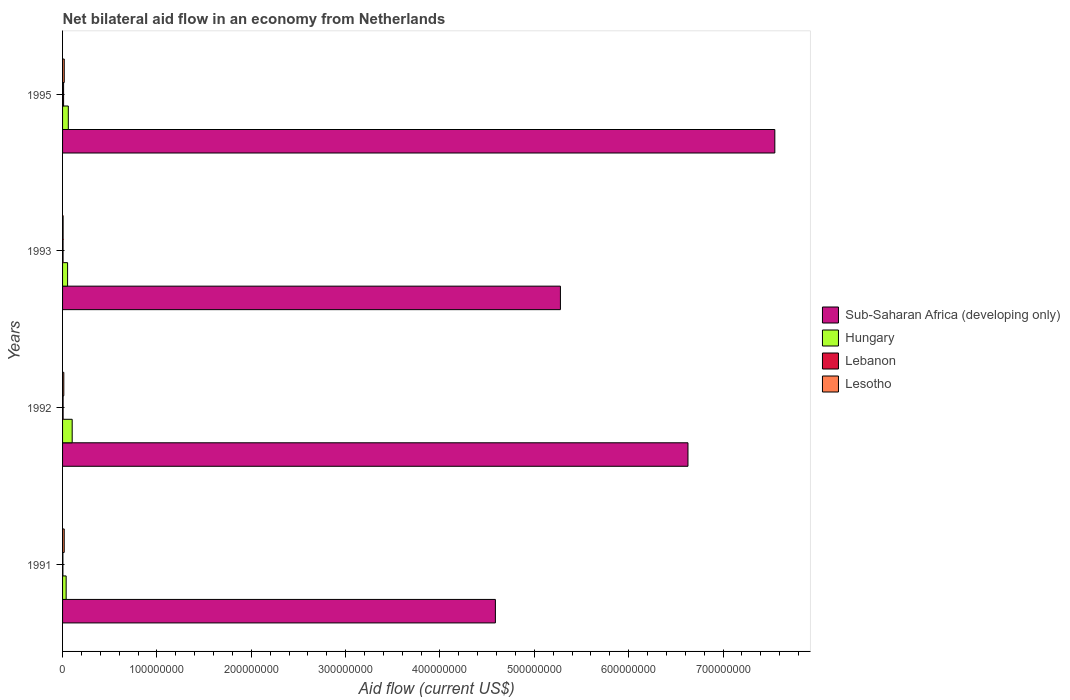Are the number of bars per tick equal to the number of legend labels?
Provide a short and direct response. Yes. Are the number of bars on each tick of the Y-axis equal?
Your answer should be compact. Yes. How many bars are there on the 2nd tick from the top?
Provide a short and direct response. 4. How many bars are there on the 2nd tick from the bottom?
Offer a terse response. 4. What is the label of the 4th group of bars from the top?
Offer a very short reply. 1991. In how many cases, is the number of bars for a given year not equal to the number of legend labels?
Your response must be concise. 0. What is the net bilateral aid flow in Sub-Saharan Africa (developing only) in 1992?
Provide a short and direct response. 6.63e+08. Across all years, what is the maximum net bilateral aid flow in Sub-Saharan Africa (developing only)?
Give a very brief answer. 7.55e+08. Across all years, what is the minimum net bilateral aid flow in Sub-Saharan Africa (developing only)?
Keep it short and to the point. 4.59e+08. In which year was the net bilateral aid flow in Hungary maximum?
Make the answer very short. 1992. In which year was the net bilateral aid flow in Lesotho minimum?
Offer a very short reply. 1993. What is the total net bilateral aid flow in Lebanon in the graph?
Keep it short and to the point. 2.55e+06. What is the difference between the net bilateral aid flow in Lesotho in 1993 and that in 1995?
Offer a very short reply. -1.20e+06. What is the difference between the net bilateral aid flow in Lesotho in 1991 and the net bilateral aid flow in Sub-Saharan Africa (developing only) in 1995?
Offer a terse response. -7.53e+08. What is the average net bilateral aid flow in Hungary per year?
Provide a succinct answer. 6.36e+06. In the year 1993, what is the difference between the net bilateral aid flow in Hungary and net bilateral aid flow in Lesotho?
Ensure brevity in your answer.  4.75e+06. What is the ratio of the net bilateral aid flow in Lebanon in 1991 to that in 1995?
Provide a succinct answer. 0.33. What is the difference between the highest and the lowest net bilateral aid flow in Sub-Saharan Africa (developing only)?
Ensure brevity in your answer.  2.96e+08. In how many years, is the net bilateral aid flow in Sub-Saharan Africa (developing only) greater than the average net bilateral aid flow in Sub-Saharan Africa (developing only) taken over all years?
Make the answer very short. 2. Is the sum of the net bilateral aid flow in Lebanon in 1991 and 1992 greater than the maximum net bilateral aid flow in Hungary across all years?
Keep it short and to the point. No. What does the 1st bar from the top in 1993 represents?
Your answer should be compact. Lesotho. What does the 2nd bar from the bottom in 1991 represents?
Offer a terse response. Hungary. Is it the case that in every year, the sum of the net bilateral aid flow in Sub-Saharan Africa (developing only) and net bilateral aid flow in Hungary is greater than the net bilateral aid flow in Lesotho?
Your answer should be very brief. Yes. How many bars are there?
Make the answer very short. 16. Are all the bars in the graph horizontal?
Provide a short and direct response. Yes. How many years are there in the graph?
Give a very brief answer. 4. Are the values on the major ticks of X-axis written in scientific E-notation?
Provide a short and direct response. No. Does the graph contain any zero values?
Your answer should be compact. No. How many legend labels are there?
Provide a succinct answer. 4. What is the title of the graph?
Offer a terse response. Net bilateral aid flow in an economy from Netherlands. Does "Guinea-Bissau" appear as one of the legend labels in the graph?
Ensure brevity in your answer.  No. What is the label or title of the X-axis?
Offer a very short reply. Aid flow (current US$). What is the label or title of the Y-axis?
Your response must be concise. Years. What is the Aid flow (current US$) in Sub-Saharan Africa (developing only) in 1991?
Your answer should be compact. 4.59e+08. What is the Aid flow (current US$) of Hungary in 1991?
Make the answer very short. 3.80e+06. What is the Aid flow (current US$) of Lebanon in 1991?
Provide a succinct answer. 3.60e+05. What is the Aid flow (current US$) in Lesotho in 1991?
Offer a very short reply. 1.75e+06. What is the Aid flow (current US$) of Sub-Saharan Africa (developing only) in 1992?
Offer a terse response. 6.63e+08. What is the Aid flow (current US$) in Hungary in 1992?
Keep it short and to the point. 1.02e+07. What is the Aid flow (current US$) in Lebanon in 1992?
Your answer should be very brief. 5.80e+05. What is the Aid flow (current US$) of Lesotho in 1992?
Make the answer very short. 1.32e+06. What is the Aid flow (current US$) in Sub-Saharan Africa (developing only) in 1993?
Your answer should be very brief. 5.28e+08. What is the Aid flow (current US$) of Hungary in 1993?
Offer a terse response. 5.33e+06. What is the Aid flow (current US$) of Lebanon in 1993?
Your answer should be very brief. 5.20e+05. What is the Aid flow (current US$) of Lesotho in 1993?
Ensure brevity in your answer.  5.80e+05. What is the Aid flow (current US$) in Sub-Saharan Africa (developing only) in 1995?
Give a very brief answer. 7.55e+08. What is the Aid flow (current US$) in Hungary in 1995?
Make the answer very short. 6.09e+06. What is the Aid flow (current US$) of Lebanon in 1995?
Ensure brevity in your answer.  1.09e+06. What is the Aid flow (current US$) in Lesotho in 1995?
Ensure brevity in your answer.  1.78e+06. Across all years, what is the maximum Aid flow (current US$) of Sub-Saharan Africa (developing only)?
Provide a short and direct response. 7.55e+08. Across all years, what is the maximum Aid flow (current US$) of Hungary?
Provide a succinct answer. 1.02e+07. Across all years, what is the maximum Aid flow (current US$) of Lebanon?
Ensure brevity in your answer.  1.09e+06. Across all years, what is the maximum Aid flow (current US$) in Lesotho?
Your answer should be very brief. 1.78e+06. Across all years, what is the minimum Aid flow (current US$) in Sub-Saharan Africa (developing only)?
Offer a very short reply. 4.59e+08. Across all years, what is the minimum Aid flow (current US$) of Hungary?
Offer a terse response. 3.80e+06. Across all years, what is the minimum Aid flow (current US$) of Lebanon?
Provide a short and direct response. 3.60e+05. Across all years, what is the minimum Aid flow (current US$) in Lesotho?
Keep it short and to the point. 5.80e+05. What is the total Aid flow (current US$) in Sub-Saharan Africa (developing only) in the graph?
Your response must be concise. 2.40e+09. What is the total Aid flow (current US$) in Hungary in the graph?
Your response must be concise. 2.54e+07. What is the total Aid flow (current US$) in Lebanon in the graph?
Provide a short and direct response. 2.55e+06. What is the total Aid flow (current US$) of Lesotho in the graph?
Give a very brief answer. 5.43e+06. What is the difference between the Aid flow (current US$) of Sub-Saharan Africa (developing only) in 1991 and that in 1992?
Provide a succinct answer. -2.04e+08. What is the difference between the Aid flow (current US$) in Hungary in 1991 and that in 1992?
Your response must be concise. -6.40e+06. What is the difference between the Aid flow (current US$) in Sub-Saharan Africa (developing only) in 1991 and that in 1993?
Provide a short and direct response. -6.89e+07. What is the difference between the Aid flow (current US$) of Hungary in 1991 and that in 1993?
Your answer should be very brief. -1.53e+06. What is the difference between the Aid flow (current US$) of Lesotho in 1991 and that in 1993?
Provide a succinct answer. 1.17e+06. What is the difference between the Aid flow (current US$) of Sub-Saharan Africa (developing only) in 1991 and that in 1995?
Your response must be concise. -2.96e+08. What is the difference between the Aid flow (current US$) in Hungary in 1991 and that in 1995?
Provide a succinct answer. -2.29e+06. What is the difference between the Aid flow (current US$) in Lebanon in 1991 and that in 1995?
Make the answer very short. -7.30e+05. What is the difference between the Aid flow (current US$) in Sub-Saharan Africa (developing only) in 1992 and that in 1993?
Your response must be concise. 1.35e+08. What is the difference between the Aid flow (current US$) of Hungary in 1992 and that in 1993?
Offer a terse response. 4.87e+06. What is the difference between the Aid flow (current US$) of Lesotho in 1992 and that in 1993?
Provide a succinct answer. 7.40e+05. What is the difference between the Aid flow (current US$) in Sub-Saharan Africa (developing only) in 1992 and that in 1995?
Offer a very short reply. -9.21e+07. What is the difference between the Aid flow (current US$) in Hungary in 1992 and that in 1995?
Offer a very short reply. 4.11e+06. What is the difference between the Aid flow (current US$) of Lebanon in 1992 and that in 1995?
Make the answer very short. -5.10e+05. What is the difference between the Aid flow (current US$) of Lesotho in 1992 and that in 1995?
Provide a short and direct response. -4.60e+05. What is the difference between the Aid flow (current US$) in Sub-Saharan Africa (developing only) in 1993 and that in 1995?
Provide a succinct answer. -2.27e+08. What is the difference between the Aid flow (current US$) in Hungary in 1993 and that in 1995?
Offer a very short reply. -7.60e+05. What is the difference between the Aid flow (current US$) of Lebanon in 1993 and that in 1995?
Keep it short and to the point. -5.70e+05. What is the difference between the Aid flow (current US$) in Lesotho in 1993 and that in 1995?
Make the answer very short. -1.20e+06. What is the difference between the Aid flow (current US$) in Sub-Saharan Africa (developing only) in 1991 and the Aid flow (current US$) in Hungary in 1992?
Your answer should be compact. 4.49e+08. What is the difference between the Aid flow (current US$) in Sub-Saharan Africa (developing only) in 1991 and the Aid flow (current US$) in Lebanon in 1992?
Make the answer very short. 4.58e+08. What is the difference between the Aid flow (current US$) of Sub-Saharan Africa (developing only) in 1991 and the Aid flow (current US$) of Lesotho in 1992?
Ensure brevity in your answer.  4.57e+08. What is the difference between the Aid flow (current US$) of Hungary in 1991 and the Aid flow (current US$) of Lebanon in 1992?
Offer a very short reply. 3.22e+06. What is the difference between the Aid flow (current US$) of Hungary in 1991 and the Aid flow (current US$) of Lesotho in 1992?
Offer a very short reply. 2.48e+06. What is the difference between the Aid flow (current US$) in Lebanon in 1991 and the Aid flow (current US$) in Lesotho in 1992?
Make the answer very short. -9.60e+05. What is the difference between the Aid flow (current US$) of Sub-Saharan Africa (developing only) in 1991 and the Aid flow (current US$) of Hungary in 1993?
Give a very brief answer. 4.53e+08. What is the difference between the Aid flow (current US$) in Sub-Saharan Africa (developing only) in 1991 and the Aid flow (current US$) in Lebanon in 1993?
Your answer should be compact. 4.58e+08. What is the difference between the Aid flow (current US$) in Sub-Saharan Africa (developing only) in 1991 and the Aid flow (current US$) in Lesotho in 1993?
Make the answer very short. 4.58e+08. What is the difference between the Aid flow (current US$) of Hungary in 1991 and the Aid flow (current US$) of Lebanon in 1993?
Your response must be concise. 3.28e+06. What is the difference between the Aid flow (current US$) of Hungary in 1991 and the Aid flow (current US$) of Lesotho in 1993?
Your response must be concise. 3.22e+06. What is the difference between the Aid flow (current US$) in Lebanon in 1991 and the Aid flow (current US$) in Lesotho in 1993?
Your answer should be compact. -2.20e+05. What is the difference between the Aid flow (current US$) in Sub-Saharan Africa (developing only) in 1991 and the Aid flow (current US$) in Hungary in 1995?
Offer a very short reply. 4.53e+08. What is the difference between the Aid flow (current US$) of Sub-Saharan Africa (developing only) in 1991 and the Aid flow (current US$) of Lebanon in 1995?
Your answer should be very brief. 4.58e+08. What is the difference between the Aid flow (current US$) in Sub-Saharan Africa (developing only) in 1991 and the Aid flow (current US$) in Lesotho in 1995?
Your response must be concise. 4.57e+08. What is the difference between the Aid flow (current US$) of Hungary in 1991 and the Aid flow (current US$) of Lebanon in 1995?
Ensure brevity in your answer.  2.71e+06. What is the difference between the Aid flow (current US$) of Hungary in 1991 and the Aid flow (current US$) of Lesotho in 1995?
Offer a very short reply. 2.02e+06. What is the difference between the Aid flow (current US$) in Lebanon in 1991 and the Aid flow (current US$) in Lesotho in 1995?
Provide a succinct answer. -1.42e+06. What is the difference between the Aid flow (current US$) of Sub-Saharan Africa (developing only) in 1992 and the Aid flow (current US$) of Hungary in 1993?
Your answer should be compact. 6.58e+08. What is the difference between the Aid flow (current US$) in Sub-Saharan Africa (developing only) in 1992 and the Aid flow (current US$) in Lebanon in 1993?
Give a very brief answer. 6.62e+08. What is the difference between the Aid flow (current US$) in Sub-Saharan Africa (developing only) in 1992 and the Aid flow (current US$) in Lesotho in 1993?
Your response must be concise. 6.62e+08. What is the difference between the Aid flow (current US$) of Hungary in 1992 and the Aid flow (current US$) of Lebanon in 1993?
Ensure brevity in your answer.  9.68e+06. What is the difference between the Aid flow (current US$) of Hungary in 1992 and the Aid flow (current US$) of Lesotho in 1993?
Make the answer very short. 9.62e+06. What is the difference between the Aid flow (current US$) of Sub-Saharan Africa (developing only) in 1992 and the Aid flow (current US$) of Hungary in 1995?
Your response must be concise. 6.57e+08. What is the difference between the Aid flow (current US$) in Sub-Saharan Africa (developing only) in 1992 and the Aid flow (current US$) in Lebanon in 1995?
Make the answer very short. 6.62e+08. What is the difference between the Aid flow (current US$) of Sub-Saharan Africa (developing only) in 1992 and the Aid flow (current US$) of Lesotho in 1995?
Provide a succinct answer. 6.61e+08. What is the difference between the Aid flow (current US$) of Hungary in 1992 and the Aid flow (current US$) of Lebanon in 1995?
Provide a short and direct response. 9.11e+06. What is the difference between the Aid flow (current US$) of Hungary in 1992 and the Aid flow (current US$) of Lesotho in 1995?
Your response must be concise. 8.42e+06. What is the difference between the Aid flow (current US$) in Lebanon in 1992 and the Aid flow (current US$) in Lesotho in 1995?
Offer a terse response. -1.20e+06. What is the difference between the Aid flow (current US$) in Sub-Saharan Africa (developing only) in 1993 and the Aid flow (current US$) in Hungary in 1995?
Provide a succinct answer. 5.22e+08. What is the difference between the Aid flow (current US$) in Sub-Saharan Africa (developing only) in 1993 and the Aid flow (current US$) in Lebanon in 1995?
Keep it short and to the point. 5.27e+08. What is the difference between the Aid flow (current US$) in Sub-Saharan Africa (developing only) in 1993 and the Aid flow (current US$) in Lesotho in 1995?
Offer a terse response. 5.26e+08. What is the difference between the Aid flow (current US$) in Hungary in 1993 and the Aid flow (current US$) in Lebanon in 1995?
Your answer should be very brief. 4.24e+06. What is the difference between the Aid flow (current US$) of Hungary in 1993 and the Aid flow (current US$) of Lesotho in 1995?
Your response must be concise. 3.55e+06. What is the difference between the Aid flow (current US$) of Lebanon in 1993 and the Aid flow (current US$) of Lesotho in 1995?
Give a very brief answer. -1.26e+06. What is the average Aid flow (current US$) of Sub-Saharan Africa (developing only) per year?
Ensure brevity in your answer.  6.01e+08. What is the average Aid flow (current US$) of Hungary per year?
Provide a succinct answer. 6.36e+06. What is the average Aid flow (current US$) in Lebanon per year?
Make the answer very short. 6.38e+05. What is the average Aid flow (current US$) in Lesotho per year?
Your response must be concise. 1.36e+06. In the year 1991, what is the difference between the Aid flow (current US$) of Sub-Saharan Africa (developing only) and Aid flow (current US$) of Hungary?
Your response must be concise. 4.55e+08. In the year 1991, what is the difference between the Aid flow (current US$) of Sub-Saharan Africa (developing only) and Aid flow (current US$) of Lebanon?
Offer a terse response. 4.58e+08. In the year 1991, what is the difference between the Aid flow (current US$) of Sub-Saharan Africa (developing only) and Aid flow (current US$) of Lesotho?
Keep it short and to the point. 4.57e+08. In the year 1991, what is the difference between the Aid flow (current US$) of Hungary and Aid flow (current US$) of Lebanon?
Provide a succinct answer. 3.44e+06. In the year 1991, what is the difference between the Aid flow (current US$) in Hungary and Aid flow (current US$) in Lesotho?
Offer a terse response. 2.05e+06. In the year 1991, what is the difference between the Aid flow (current US$) of Lebanon and Aid flow (current US$) of Lesotho?
Your answer should be very brief. -1.39e+06. In the year 1992, what is the difference between the Aid flow (current US$) in Sub-Saharan Africa (developing only) and Aid flow (current US$) in Hungary?
Make the answer very short. 6.53e+08. In the year 1992, what is the difference between the Aid flow (current US$) in Sub-Saharan Africa (developing only) and Aid flow (current US$) in Lebanon?
Provide a succinct answer. 6.62e+08. In the year 1992, what is the difference between the Aid flow (current US$) in Sub-Saharan Africa (developing only) and Aid flow (current US$) in Lesotho?
Offer a very short reply. 6.62e+08. In the year 1992, what is the difference between the Aid flow (current US$) of Hungary and Aid flow (current US$) of Lebanon?
Your answer should be compact. 9.62e+06. In the year 1992, what is the difference between the Aid flow (current US$) of Hungary and Aid flow (current US$) of Lesotho?
Provide a succinct answer. 8.88e+06. In the year 1992, what is the difference between the Aid flow (current US$) in Lebanon and Aid flow (current US$) in Lesotho?
Offer a very short reply. -7.40e+05. In the year 1993, what is the difference between the Aid flow (current US$) in Sub-Saharan Africa (developing only) and Aid flow (current US$) in Hungary?
Provide a short and direct response. 5.22e+08. In the year 1993, what is the difference between the Aid flow (current US$) in Sub-Saharan Africa (developing only) and Aid flow (current US$) in Lebanon?
Offer a very short reply. 5.27e+08. In the year 1993, what is the difference between the Aid flow (current US$) in Sub-Saharan Africa (developing only) and Aid flow (current US$) in Lesotho?
Make the answer very short. 5.27e+08. In the year 1993, what is the difference between the Aid flow (current US$) in Hungary and Aid flow (current US$) in Lebanon?
Keep it short and to the point. 4.81e+06. In the year 1993, what is the difference between the Aid flow (current US$) of Hungary and Aid flow (current US$) of Lesotho?
Your answer should be compact. 4.75e+06. In the year 1993, what is the difference between the Aid flow (current US$) of Lebanon and Aid flow (current US$) of Lesotho?
Make the answer very short. -6.00e+04. In the year 1995, what is the difference between the Aid flow (current US$) in Sub-Saharan Africa (developing only) and Aid flow (current US$) in Hungary?
Make the answer very short. 7.49e+08. In the year 1995, what is the difference between the Aid flow (current US$) of Sub-Saharan Africa (developing only) and Aid flow (current US$) of Lebanon?
Offer a very short reply. 7.54e+08. In the year 1995, what is the difference between the Aid flow (current US$) of Sub-Saharan Africa (developing only) and Aid flow (current US$) of Lesotho?
Your answer should be very brief. 7.53e+08. In the year 1995, what is the difference between the Aid flow (current US$) of Hungary and Aid flow (current US$) of Lesotho?
Your answer should be compact. 4.31e+06. In the year 1995, what is the difference between the Aid flow (current US$) of Lebanon and Aid flow (current US$) of Lesotho?
Your response must be concise. -6.90e+05. What is the ratio of the Aid flow (current US$) of Sub-Saharan Africa (developing only) in 1991 to that in 1992?
Offer a very short reply. 0.69. What is the ratio of the Aid flow (current US$) of Hungary in 1991 to that in 1992?
Offer a very short reply. 0.37. What is the ratio of the Aid flow (current US$) in Lebanon in 1991 to that in 1992?
Offer a terse response. 0.62. What is the ratio of the Aid flow (current US$) in Lesotho in 1991 to that in 1992?
Keep it short and to the point. 1.33. What is the ratio of the Aid flow (current US$) of Sub-Saharan Africa (developing only) in 1991 to that in 1993?
Keep it short and to the point. 0.87. What is the ratio of the Aid flow (current US$) in Hungary in 1991 to that in 1993?
Offer a very short reply. 0.71. What is the ratio of the Aid flow (current US$) in Lebanon in 1991 to that in 1993?
Give a very brief answer. 0.69. What is the ratio of the Aid flow (current US$) of Lesotho in 1991 to that in 1993?
Provide a succinct answer. 3.02. What is the ratio of the Aid flow (current US$) in Sub-Saharan Africa (developing only) in 1991 to that in 1995?
Your answer should be compact. 0.61. What is the ratio of the Aid flow (current US$) of Hungary in 1991 to that in 1995?
Your response must be concise. 0.62. What is the ratio of the Aid flow (current US$) of Lebanon in 1991 to that in 1995?
Offer a very short reply. 0.33. What is the ratio of the Aid flow (current US$) of Lesotho in 1991 to that in 1995?
Give a very brief answer. 0.98. What is the ratio of the Aid flow (current US$) in Sub-Saharan Africa (developing only) in 1992 to that in 1993?
Offer a very short reply. 1.26. What is the ratio of the Aid flow (current US$) of Hungary in 1992 to that in 1993?
Your response must be concise. 1.91. What is the ratio of the Aid flow (current US$) in Lebanon in 1992 to that in 1993?
Give a very brief answer. 1.12. What is the ratio of the Aid flow (current US$) in Lesotho in 1992 to that in 1993?
Your answer should be compact. 2.28. What is the ratio of the Aid flow (current US$) in Sub-Saharan Africa (developing only) in 1992 to that in 1995?
Your answer should be compact. 0.88. What is the ratio of the Aid flow (current US$) of Hungary in 1992 to that in 1995?
Offer a terse response. 1.67. What is the ratio of the Aid flow (current US$) of Lebanon in 1992 to that in 1995?
Keep it short and to the point. 0.53. What is the ratio of the Aid flow (current US$) in Lesotho in 1992 to that in 1995?
Offer a terse response. 0.74. What is the ratio of the Aid flow (current US$) of Sub-Saharan Africa (developing only) in 1993 to that in 1995?
Make the answer very short. 0.7. What is the ratio of the Aid flow (current US$) in Hungary in 1993 to that in 1995?
Offer a terse response. 0.88. What is the ratio of the Aid flow (current US$) in Lebanon in 1993 to that in 1995?
Your answer should be very brief. 0.48. What is the ratio of the Aid flow (current US$) in Lesotho in 1993 to that in 1995?
Offer a terse response. 0.33. What is the difference between the highest and the second highest Aid flow (current US$) of Sub-Saharan Africa (developing only)?
Give a very brief answer. 9.21e+07. What is the difference between the highest and the second highest Aid flow (current US$) of Hungary?
Ensure brevity in your answer.  4.11e+06. What is the difference between the highest and the second highest Aid flow (current US$) of Lebanon?
Offer a very short reply. 5.10e+05. What is the difference between the highest and the second highest Aid flow (current US$) of Lesotho?
Your answer should be very brief. 3.00e+04. What is the difference between the highest and the lowest Aid flow (current US$) in Sub-Saharan Africa (developing only)?
Your answer should be compact. 2.96e+08. What is the difference between the highest and the lowest Aid flow (current US$) in Hungary?
Provide a short and direct response. 6.40e+06. What is the difference between the highest and the lowest Aid flow (current US$) of Lebanon?
Ensure brevity in your answer.  7.30e+05. What is the difference between the highest and the lowest Aid flow (current US$) of Lesotho?
Your answer should be compact. 1.20e+06. 